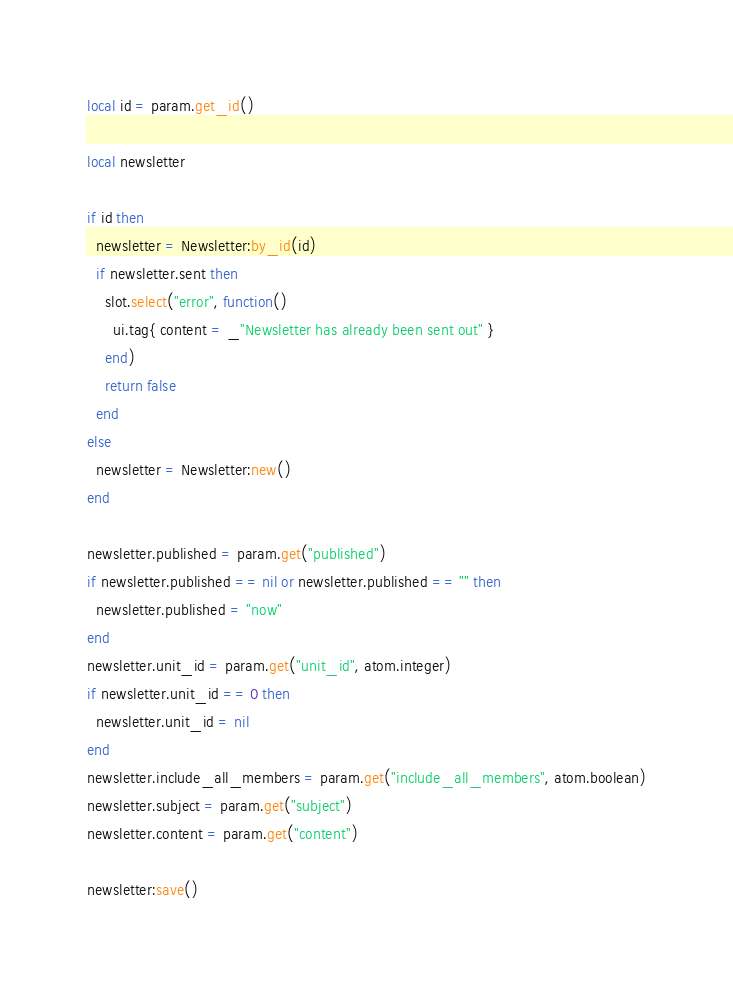<code> <loc_0><loc_0><loc_500><loc_500><_Lua_>local id = param.get_id()

local newsletter

if id then
  newsletter = Newsletter:by_id(id)
  if newsletter.sent then
    slot.select("error", function()
      ui.tag{ content = _"Newsletter has already been sent out" }
    end)
    return false
  end
else
  newsletter = Newsletter:new()
end

newsletter.published = param.get("published")
if newsletter.published == nil or newsletter.published == "" then
  newsletter.published = "now"
end
newsletter.unit_id = param.get("unit_id", atom.integer)
if newsletter.unit_id == 0 then
  newsletter.unit_id = nil
end
newsletter.include_all_members = param.get("include_all_members", atom.boolean)
newsletter.subject = param.get("subject")
newsletter.content = param.get("content")

newsletter:save()
</code> 